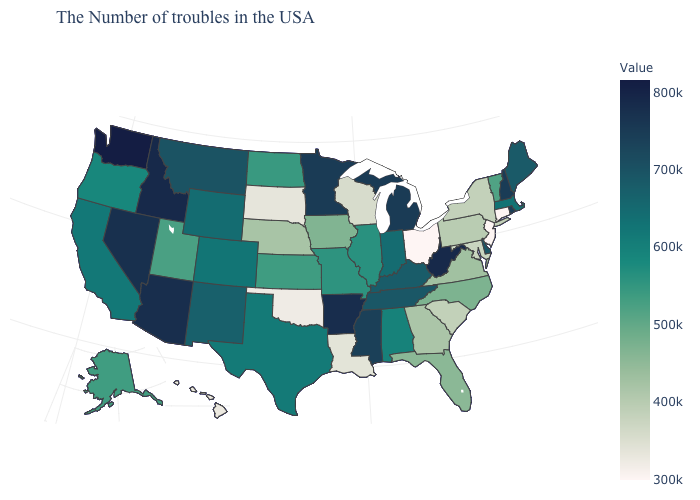Does Oregon have a higher value than New Hampshire?
Give a very brief answer. No. Is the legend a continuous bar?
Answer briefly. Yes. Among the states that border Colorado , which have the lowest value?
Keep it brief. Oklahoma. Among the states that border Virginia , does Maryland have the lowest value?
Quick response, please. Yes. Is the legend a continuous bar?
Be succinct. Yes. Does the map have missing data?
Be succinct. No. Which states have the highest value in the USA?
Concise answer only. Washington. 